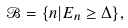<formula> <loc_0><loc_0><loc_500><loc_500>\mathcal { B } = \{ n | E _ { n } \geq \Delta \} ,</formula> 